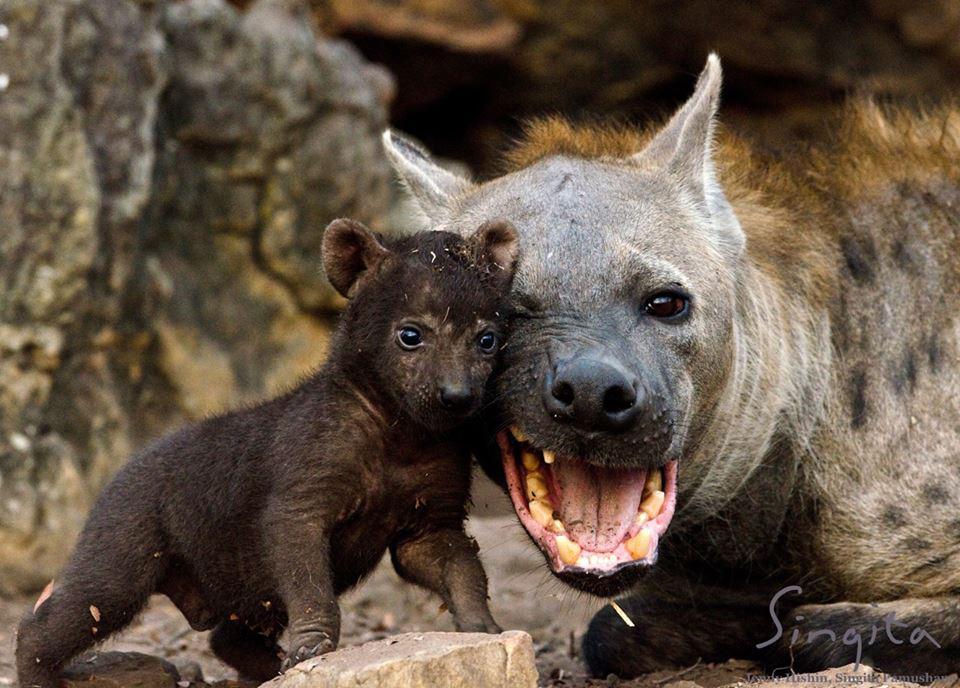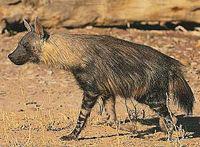The first image is the image on the left, the second image is the image on the right. For the images displayed, is the sentence "One image shows a dog-like animal walking with its body and head in profile and its hindquarters sloped lower than its shoulders." factually correct? Answer yes or no. Yes. The first image is the image on the left, the second image is the image on the right. Considering the images on both sides, is "There is a single hyena in each of the images." valid? Answer yes or no. No. 